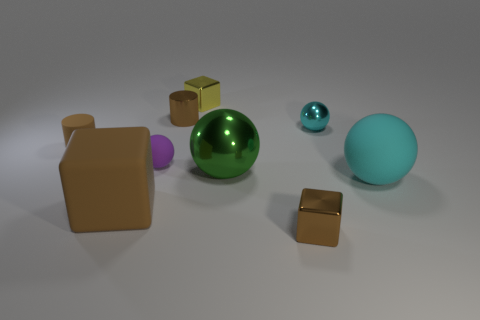How many matte things have the same color as the large matte block?
Your answer should be compact. 1. How many purple matte cylinders are there?
Provide a succinct answer. 0. What size is the matte thing in front of the big cyan rubber sphere?
Keep it short and to the point. Large. Is the number of small cyan balls that are left of the green metallic sphere the same as the number of small purple matte things?
Give a very brief answer. No. Are there any big cyan objects that have the same shape as the tiny cyan metal object?
Provide a succinct answer. Yes. What shape is the thing that is both behind the big rubber sphere and in front of the small purple object?
Provide a short and direct response. Sphere. Do the small cyan ball and the brown cube to the left of the small yellow block have the same material?
Your answer should be very brief. No. There is a brown matte cylinder; are there any brown cylinders to the right of it?
Make the answer very short. Yes. How many objects are small yellow cubes or tiny things that are on the right side of the brown matte block?
Your answer should be very brief. 5. There is a small metal block that is in front of the tiny metal thing that is to the right of the small brown metal block; what color is it?
Keep it short and to the point. Brown. 